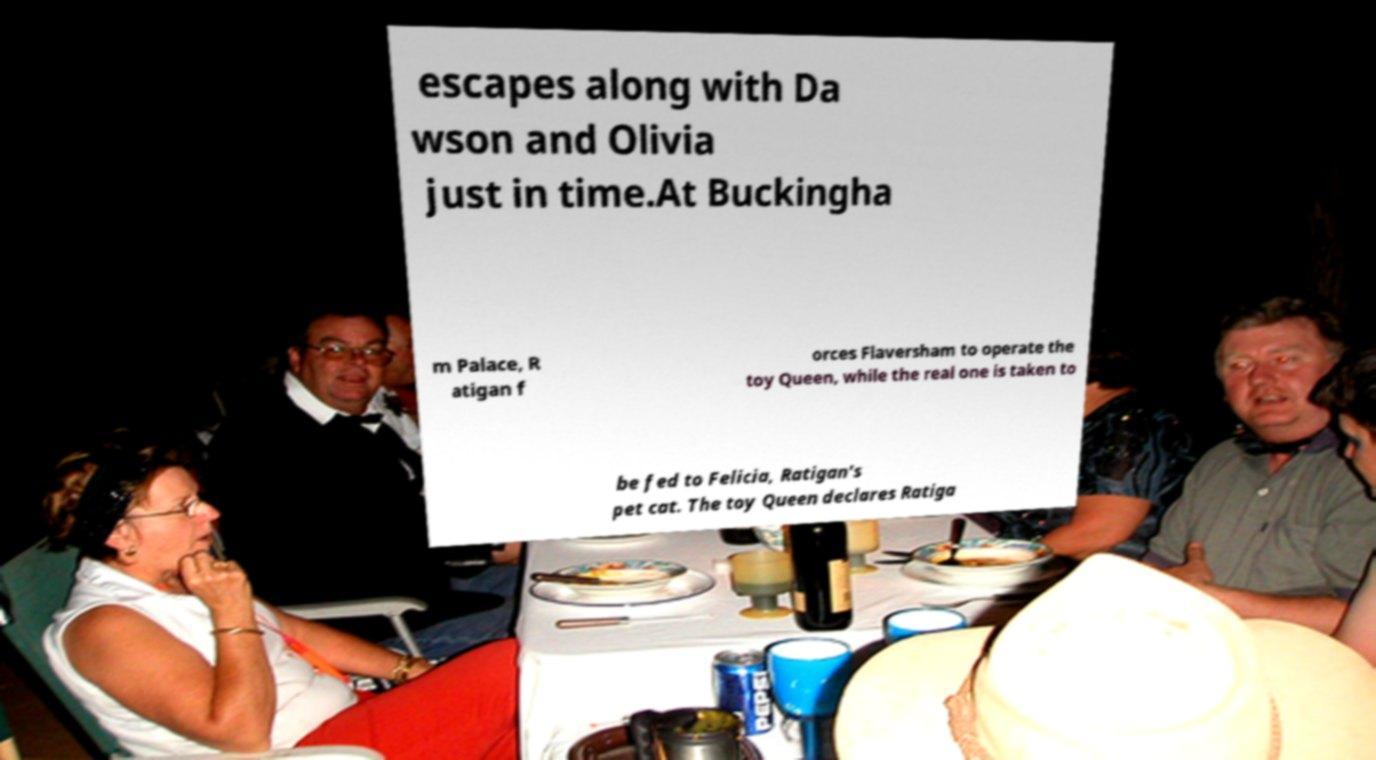Could you assist in decoding the text presented in this image and type it out clearly? escapes along with Da wson and Olivia just in time.At Buckingha m Palace, R atigan f orces Flaversham to operate the toy Queen, while the real one is taken to be fed to Felicia, Ratigan's pet cat. The toy Queen declares Ratiga 